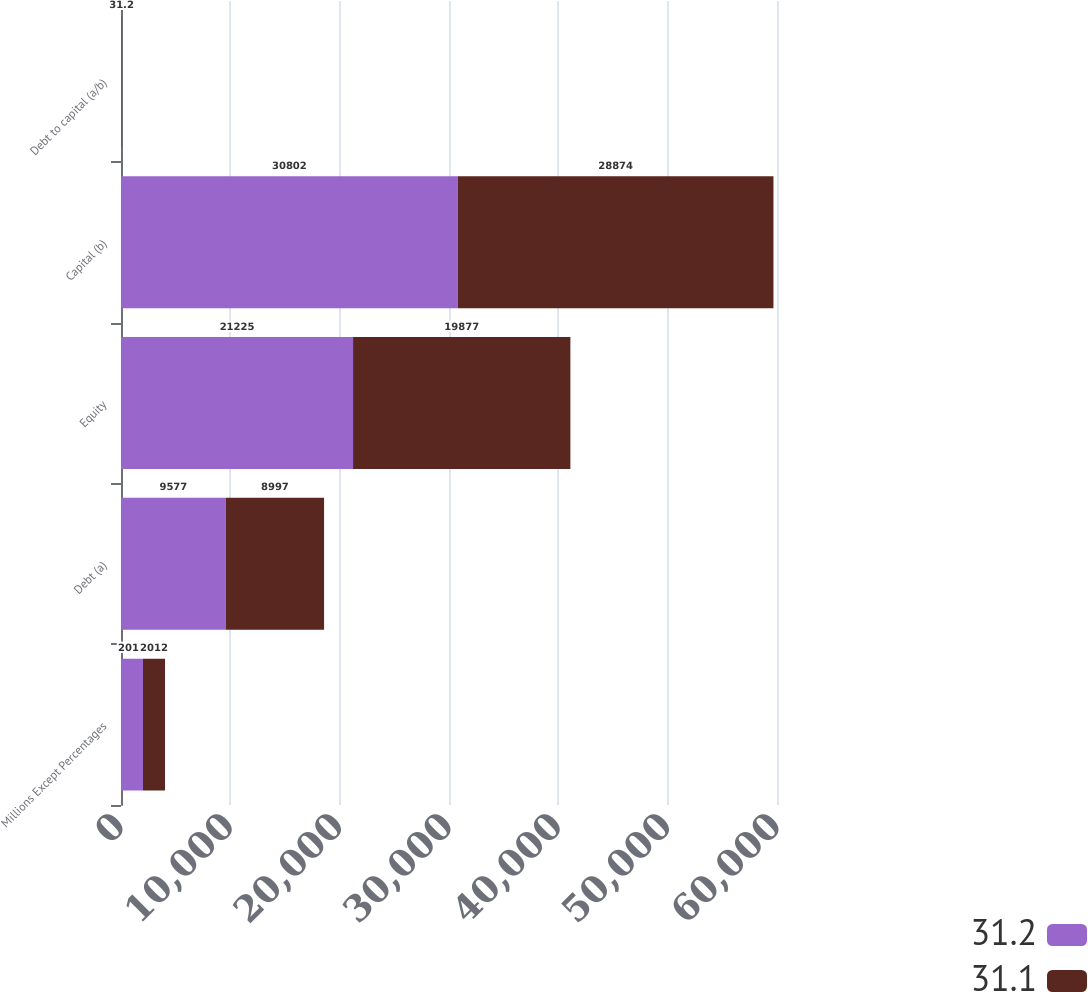Convert chart. <chart><loc_0><loc_0><loc_500><loc_500><stacked_bar_chart><ecel><fcel>Millions Except Percentages<fcel>Debt (a)<fcel>Equity<fcel>Capital (b)<fcel>Debt to capital (a/b)<nl><fcel>31.2<fcel>2013<fcel>9577<fcel>21225<fcel>30802<fcel>31.1<nl><fcel>31.1<fcel>2012<fcel>8997<fcel>19877<fcel>28874<fcel>31.2<nl></chart> 